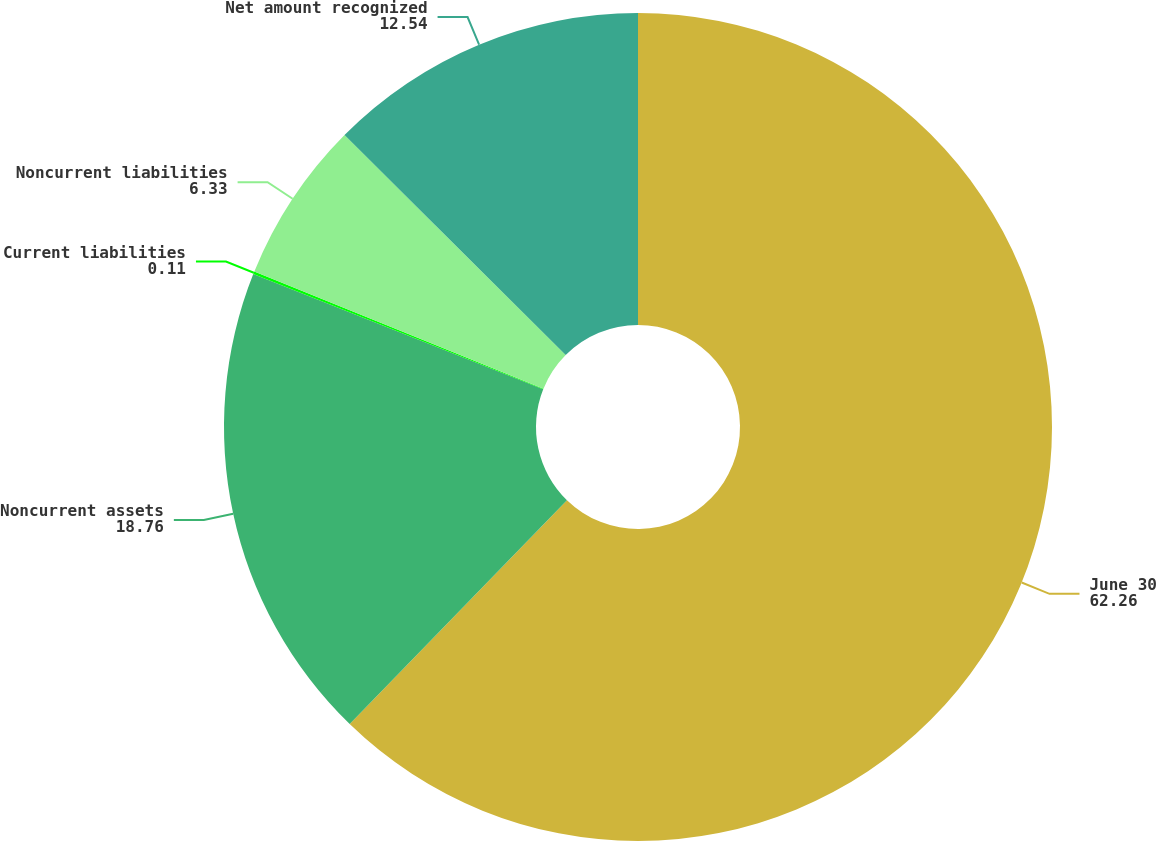<chart> <loc_0><loc_0><loc_500><loc_500><pie_chart><fcel>June 30<fcel>Noncurrent assets<fcel>Current liabilities<fcel>Noncurrent liabilities<fcel>Net amount recognized<nl><fcel>62.26%<fcel>18.76%<fcel>0.11%<fcel>6.33%<fcel>12.54%<nl></chart> 